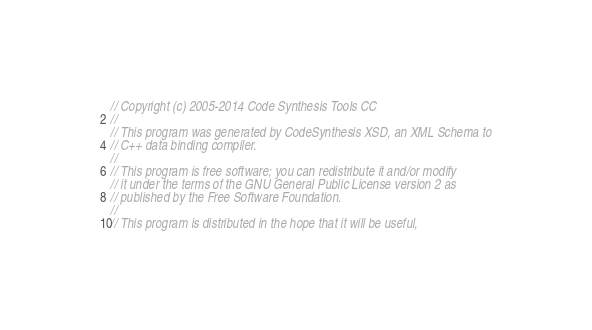<code> <loc_0><loc_0><loc_500><loc_500><_C++_>// Copyright (c) 2005-2014 Code Synthesis Tools CC
//
// This program was generated by CodeSynthesis XSD, an XML Schema to
// C++ data binding compiler.
//
// This program is free software; you can redistribute it and/or modify
// it under the terms of the GNU General Public License version 2 as
// published by the Free Software Foundation.
//
// This program is distributed in the hope that it will be useful,</code> 